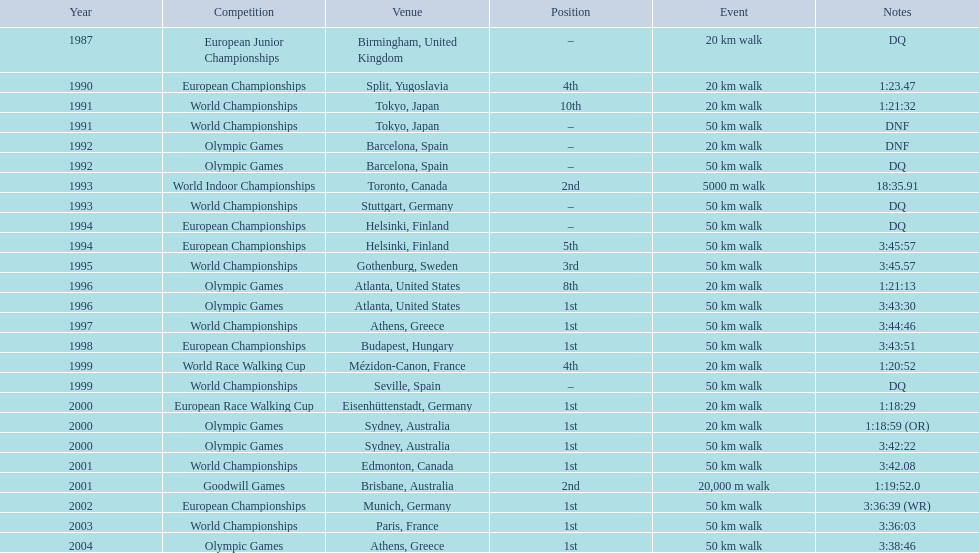How often was the position mentioned as first place? 10. 